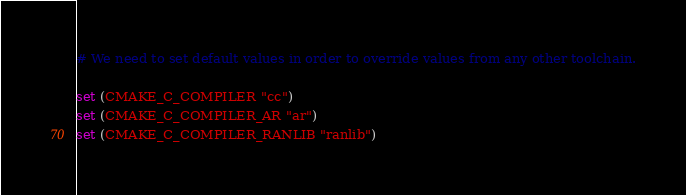<code> <loc_0><loc_0><loc_500><loc_500><_CMake_># We need to set default values in order to override values from any other toolchain.

set (CMAKE_C_COMPILER "cc")
set (CMAKE_C_COMPILER_AR "ar")
set (CMAKE_C_COMPILER_RANLIB "ranlib")
</code> 